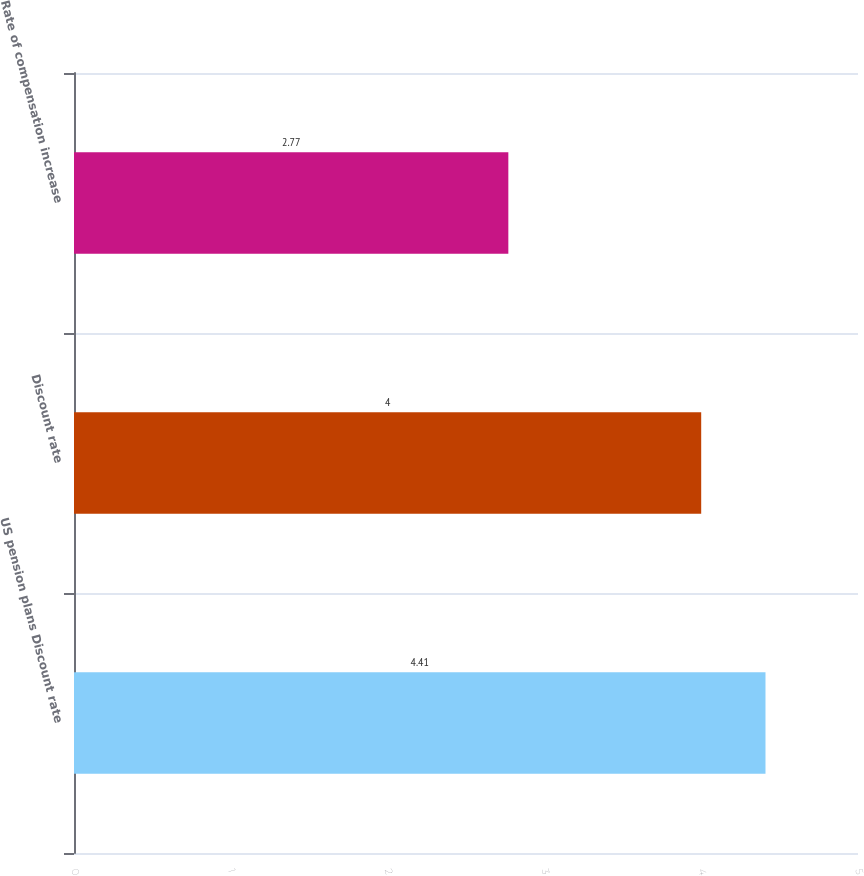Convert chart. <chart><loc_0><loc_0><loc_500><loc_500><bar_chart><fcel>US pension plans Discount rate<fcel>Discount rate<fcel>Rate of compensation increase<nl><fcel>4.41<fcel>4<fcel>2.77<nl></chart> 